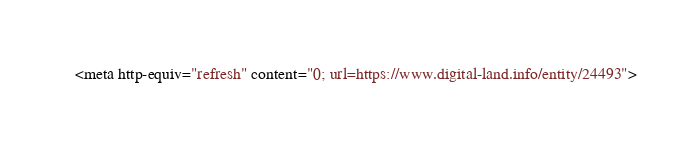<code> <loc_0><loc_0><loc_500><loc_500><_HTML_><meta http-equiv="refresh" content="0; url=https://www.digital-land.info/entity/24493"></code> 